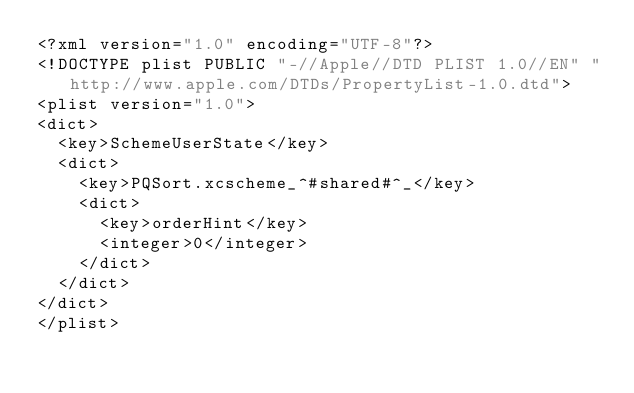Convert code to text. <code><loc_0><loc_0><loc_500><loc_500><_XML_><?xml version="1.0" encoding="UTF-8"?>
<!DOCTYPE plist PUBLIC "-//Apple//DTD PLIST 1.0//EN" "http://www.apple.com/DTDs/PropertyList-1.0.dtd">
<plist version="1.0">
<dict>
	<key>SchemeUserState</key>
	<dict>
		<key>PQSort.xcscheme_^#shared#^_</key>
		<dict>
			<key>orderHint</key>
			<integer>0</integer>
		</dict>
	</dict>
</dict>
</plist>
</code> 